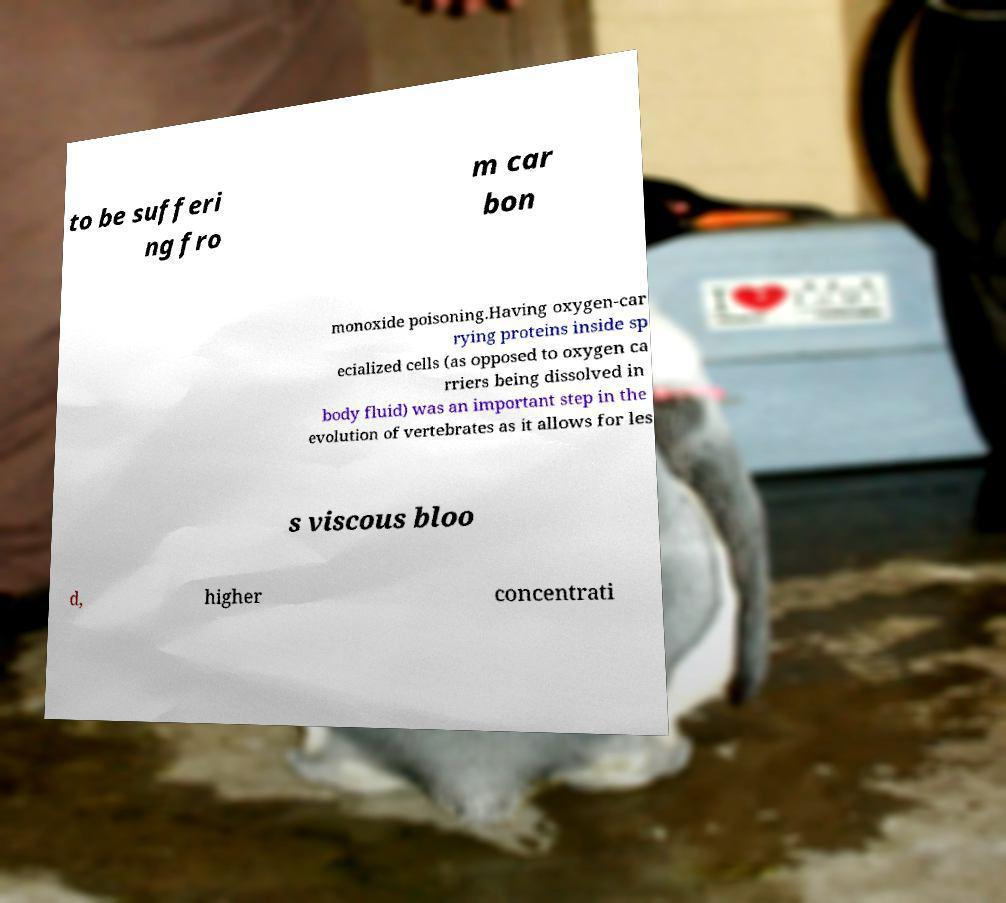Can you read and provide the text displayed in the image?This photo seems to have some interesting text. Can you extract and type it out for me? to be sufferi ng fro m car bon monoxide poisoning.Having oxygen-car rying proteins inside sp ecialized cells (as opposed to oxygen ca rriers being dissolved in body fluid) was an important step in the evolution of vertebrates as it allows for les s viscous bloo d, higher concentrati 